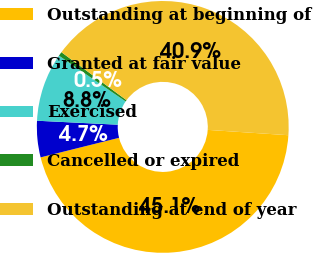<chart> <loc_0><loc_0><loc_500><loc_500><pie_chart><fcel>Outstanding at beginning of<fcel>Granted at fair value<fcel>Exercised<fcel>Cancelled or expired<fcel>Outstanding at end of year<nl><fcel>45.06%<fcel>4.67%<fcel>8.79%<fcel>0.54%<fcel>40.94%<nl></chart> 